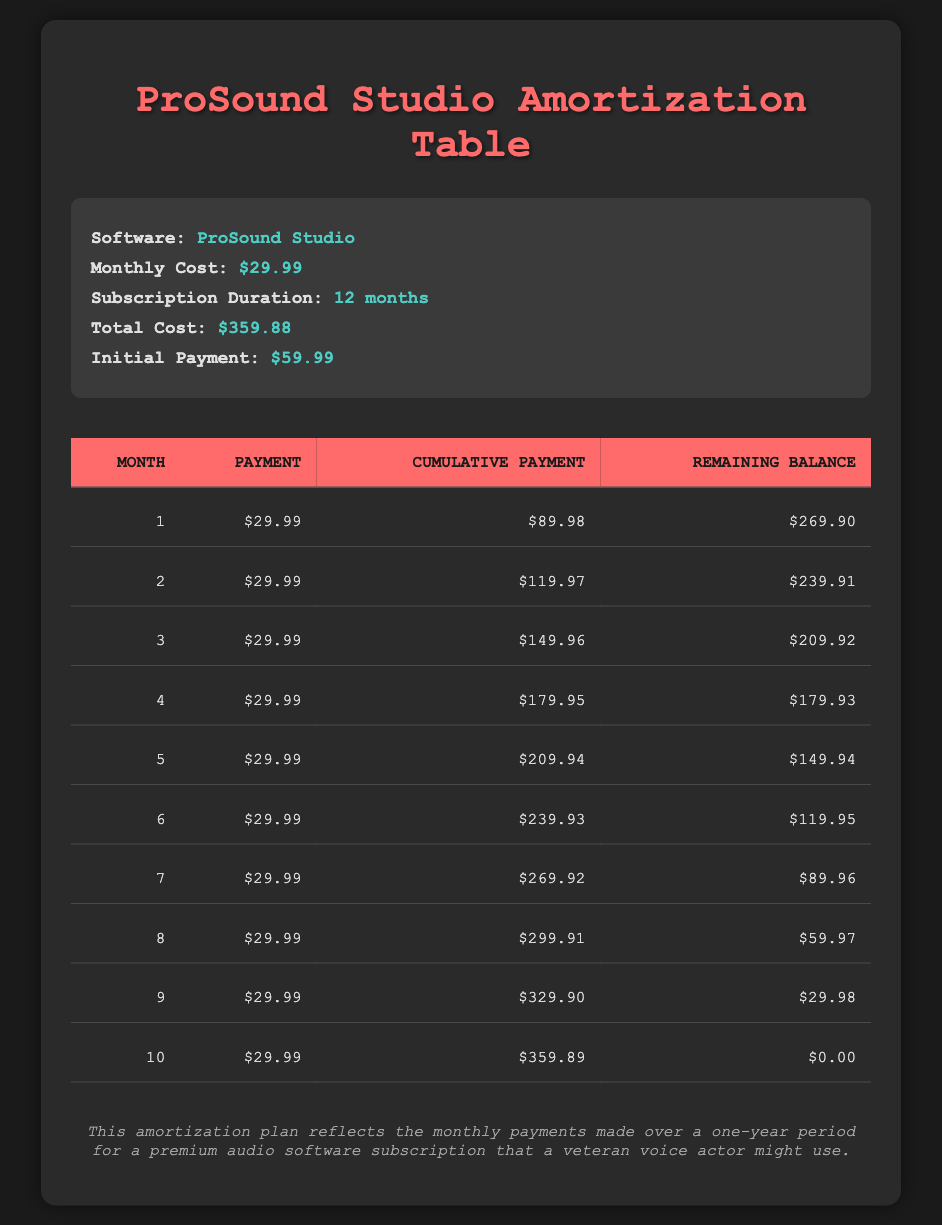What is the monthly payment for the ProSound Studio subscription? The table states that the payment for each month is consistently $29.99.
Answer: $29.99 How much have I paid cumulatively by the end of month 6? The cumulative payment after the sixth month is shown in the table as $239.93.
Answer: $239.93 What is the total cost of the ProSound Studio subscription? According to the table, the total cost for the subscription duration is $359.88.
Answer: $359.88 Is there any month where the remaining balance drops below $60? Yes, starting from month 8, the remaining balance is $59.97, which is below $60.
Answer: Yes How much was left to pay after the initial payment was made? The remaining balance after the initial payment of $59.99 is calculated as $359.88 - $59.99 = $299.89, but the table indicates $269.90 after the first month's payment.
Answer: $269.90 If I continue paying regularly, when will the remaining balance reach zero? According to the table, the remaining balance reaches zero at the end of month 10.
Answer: Month 10 What is the difference between the cumulative payment after month 5 and month 10? The cumulative payment after month 5 is $209.94, and after month 10 it is $359.89. The difference is calculated as $359.89 - $209.94 = $149.95.
Answer: $149.95 Is the cumulative payment during any month less than $150? Yes, the cumulative payment remains below $150 until the end of month 5, where it is $209.94 for month 10.
Answer: Yes How much did I pay in the final month? For the 10th month, the payment is consistently $29.99 as per the table.
Answer: $29.99 